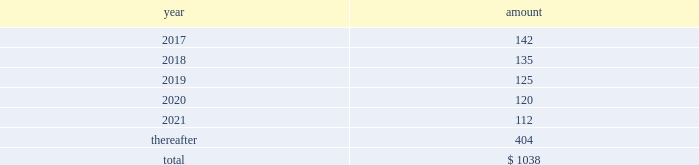Future payments that will not be paid because of an early redemption , which is discounted at a fixed spread over a comparable treasury security .
The unamortized discount and debt issuance costs are being amortized over the remaining term of the 2022 notes .
2021 notes .
In may 2011 , the company issued $ 1.5 billion in aggregate principal amount of unsecured unsubordinated obligations .
These notes were issued as two separate series of senior debt securities , including $ 750 million of 4.25% ( 4.25 % ) notes maturing in may 2021 and $ 750 million of floating rate notes , which were repaid in may 2013 at maturity .
Net proceeds of this offering were used to fund the repurchase of blackrock 2019s series b preferred from affiliates of merrill lynch & co. , inc .
Interest on the 4.25% ( 4.25 % ) notes due in 2021 ( 201c2021 notes 201d ) is payable semi-annually on may 24 and november 24 of each year , which commenced november 24 , 2011 , and is approximately $ 32 million per year .
The 2021 notes may be redeemed prior to maturity at any time in whole or in part at the option of the company at a 201cmake-whole 201d redemption price .
The unamortized discount and debt issuance costs are being amortized over the remaining term of the 2021 notes .
2019 notes .
In december 2009 , the company issued $ 2.5 billion in aggregate principal amount of unsecured and unsubordinated obligations .
These notes were issued as three separate series of senior debt securities including $ 0.5 billion of 2.25% ( 2.25 % ) notes , which were repaid in december 2012 , $ 1.0 billion of 3.50% ( 3.50 % ) notes , which were repaid in december 2014 at maturity , and $ 1.0 billion of 5.0% ( 5.0 % ) notes maturing in december 2019 ( the 201c2019 notes 201d ) .
Net proceeds of this offering were used to repay borrowings under the cp program , which was used to finance a portion of the acquisition of barclays global investors from barclays on december 1 , 2009 , and for general corporate purposes .
Interest on the 2019 notes of approximately $ 50 million per year is payable semi-annually in arrears on june 10 and december 10 of each year .
These notes may be redeemed prior to maturity at any time in whole or in part at the option of the company at a 201cmake-whole 201d redemption price .
The unamortized discount and debt issuance costs are being amortized over the remaining term of the 2019 notes .
2017 notes .
In september 2007 , the company issued $ 700 million in aggregate principal amount of 6.25% ( 6.25 % ) senior unsecured and unsubordinated notes maturing on september 15 , 2017 ( the 201c2017 notes 201d ) .
A portion of the net proceeds of the 2017 notes was used to fund the initial cash payment for the acquisition of the fund-of-funds business of quellos and the remainder was used for general corporate purposes .
Interest is payable semi-annually in arrears on march 15 and september 15 of each year , or approximately $ 44 million per year .
The 2017 notes may be redeemed prior to maturity at any time in whole or in part at the option of the company at a 201cmake-whole 201d redemption price .
The unamortized discount and debt issuance costs are being amortized over the remaining term of the 2017 notes .
13 .
Commitments and contingencies operating lease commitments the company leases its primary office spaces under agreements that expire through 2035 .
Future minimum commitments under these operating leases are as follows : ( in millions ) .
Rent expense and certain office equipment expense under lease agreements amounted to $ 134 million , $ 136 million and $ 132 million in 2016 , 2015 and 2014 , respectively .
Investment commitments .
At december 31 , 2016 , the company had $ 192 million of various capital commitments to fund sponsored investment funds , including consolidated vies .
These funds include private equity funds , real assets funds , and opportunistic funds .
This amount excludes additional commitments made by consolidated funds of funds to underlying third-party funds as third-party noncontrolling interest holders have the legal obligation to fund the respective commitments of such funds of funds .
In addition to the capital commitments of $ 192 million , the company had approximately $ 12 million of contingent commitments for certain funds which have investment periods that have expired .
Generally , the timing of the funding of these commitments is unknown and the commitments are callable on demand at any time prior to the expiration of the commitment .
These unfunded commitments are not recorded on the consolidated statements of financial condition .
These commitments do not include potential future commitments approved by the company that are not yet legally binding .
The company intends to make additional capital commitments from time to time to fund additional investment products for , and with , its clients .
Contingencies contingent payments related to business acquisitions .
In connection with certain acquisitions , blackrock is required to make contingent payments , subject to achieving specified performance targets , which may include revenue related to acquired contracts or new capital commitments for certain products .
The fair value of the remaining aggregate contingent payments at december 31 , 2016 totaled $ 115 million and is included in other liabilities on the consolidated statement of financial condition .
Other contingent payments .
The company acts as the portfolio manager in a series of derivative transactions and has a maximum potential exposure of $ 17 million between the company and counterparty .
See note 7 , derivatives and hedging , for further discussion .
Legal proceedings .
From time to time , blackrock receives subpoenas or other requests for information from various u.s .
Federal , state governmental and domestic and international regulatory authorities in connection with .
What is the expected percentage change in rent expense and certain office equipment expense in 2017? 
Computations: ((142 - 134) / 134)
Answer: 0.0597. 